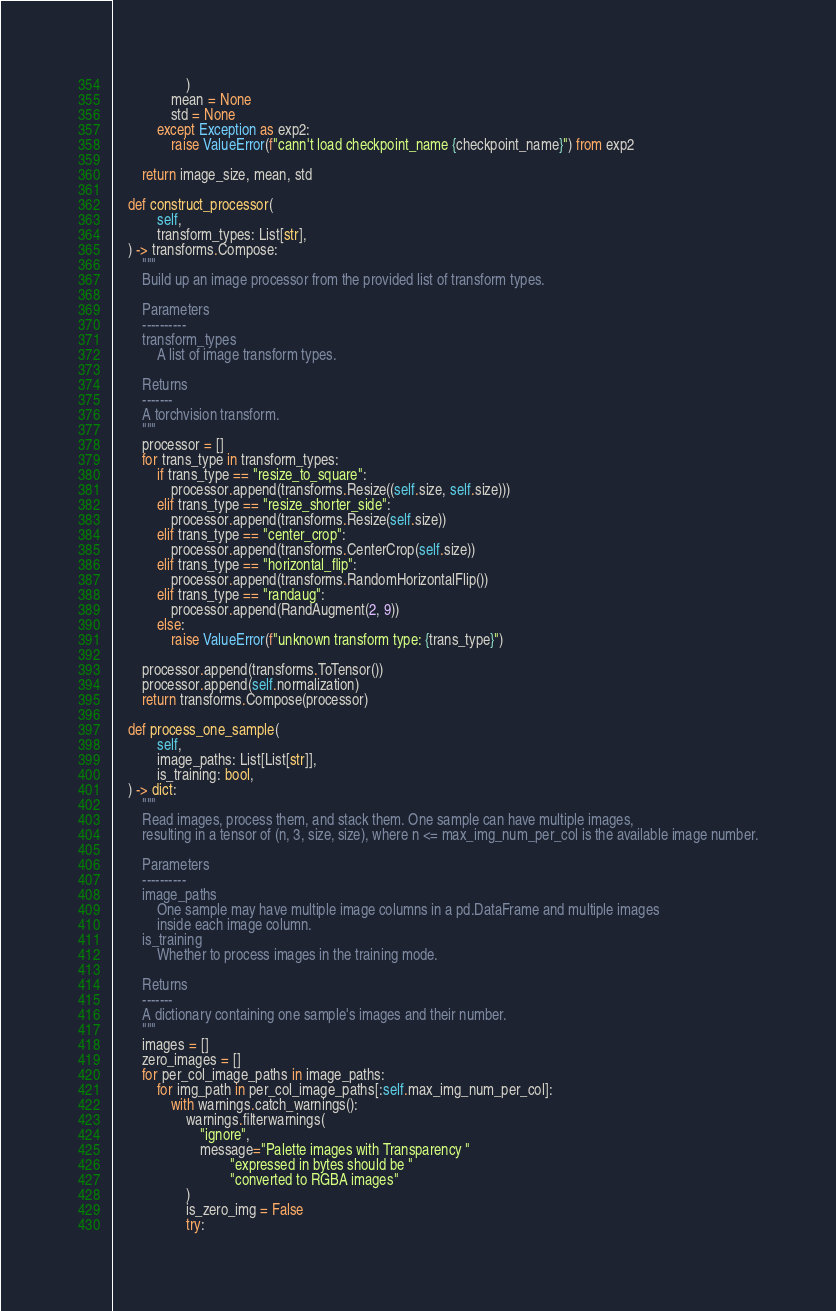Convert code to text. <code><loc_0><loc_0><loc_500><loc_500><_Python_>                    )
                mean = None
                std = None
            except Exception as exp2:
                raise ValueError(f"cann't load checkpoint_name {checkpoint_name}") from exp2

        return image_size, mean, std

    def construct_processor(
            self,
            transform_types: List[str],
    ) -> transforms.Compose:
        """
        Build up an image processor from the provided list of transform types.

        Parameters
        ----------
        transform_types
            A list of image transform types.

        Returns
        -------
        A torchvision transform.
        """
        processor = []
        for trans_type in transform_types:
            if trans_type == "resize_to_square":
                processor.append(transforms.Resize((self.size, self.size)))
            elif trans_type == "resize_shorter_side":
                processor.append(transforms.Resize(self.size))
            elif trans_type == "center_crop":
                processor.append(transforms.CenterCrop(self.size))
            elif trans_type == "horizontal_flip":
                processor.append(transforms.RandomHorizontalFlip())
            elif trans_type == "randaug":
                processor.append(RandAugment(2, 9))
            else:
                raise ValueError(f"unknown transform type: {trans_type}")

        processor.append(transforms.ToTensor())
        processor.append(self.normalization)
        return transforms.Compose(processor)

    def process_one_sample(
            self,
            image_paths: List[List[str]],
            is_training: bool,
    ) -> dict:
        """
        Read images, process them, and stack them. One sample can have multiple images,
        resulting in a tensor of (n, 3, size, size), where n <= max_img_num_per_col is the available image number.

        Parameters
        ----------
        image_paths
            One sample may have multiple image columns in a pd.DataFrame and multiple images
            inside each image column.
        is_training
            Whether to process images in the training mode.

        Returns
        -------
        A dictionary containing one sample's images and their number.
        """
        images = []
        zero_images = []
        for per_col_image_paths in image_paths:
            for img_path in per_col_image_paths[:self.max_img_num_per_col]:
                with warnings.catch_warnings():
                    warnings.filterwarnings(
                        "ignore",
                        message="Palette images with Transparency "
                                "expressed in bytes should be "
                                "converted to RGBA images"
                    )
                    is_zero_img = False
                    try:</code> 